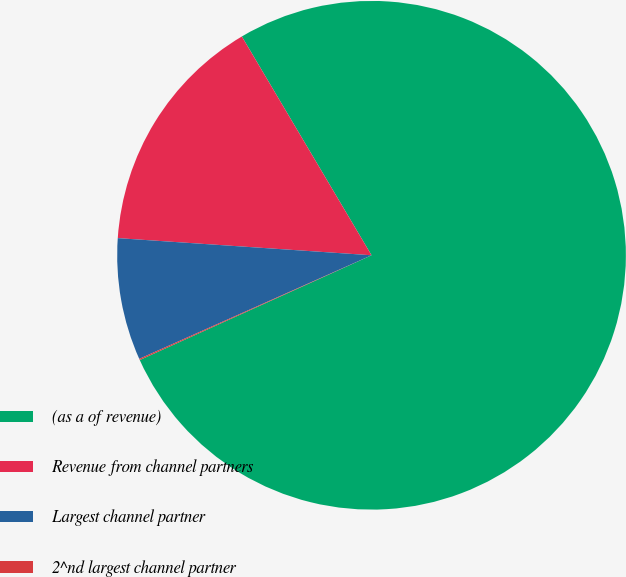Convert chart. <chart><loc_0><loc_0><loc_500><loc_500><pie_chart><fcel>(as a of revenue)<fcel>Revenue from channel partners<fcel>Largest channel partner<fcel>2^nd largest channel partner<nl><fcel>76.76%<fcel>15.41%<fcel>7.75%<fcel>0.08%<nl></chart> 